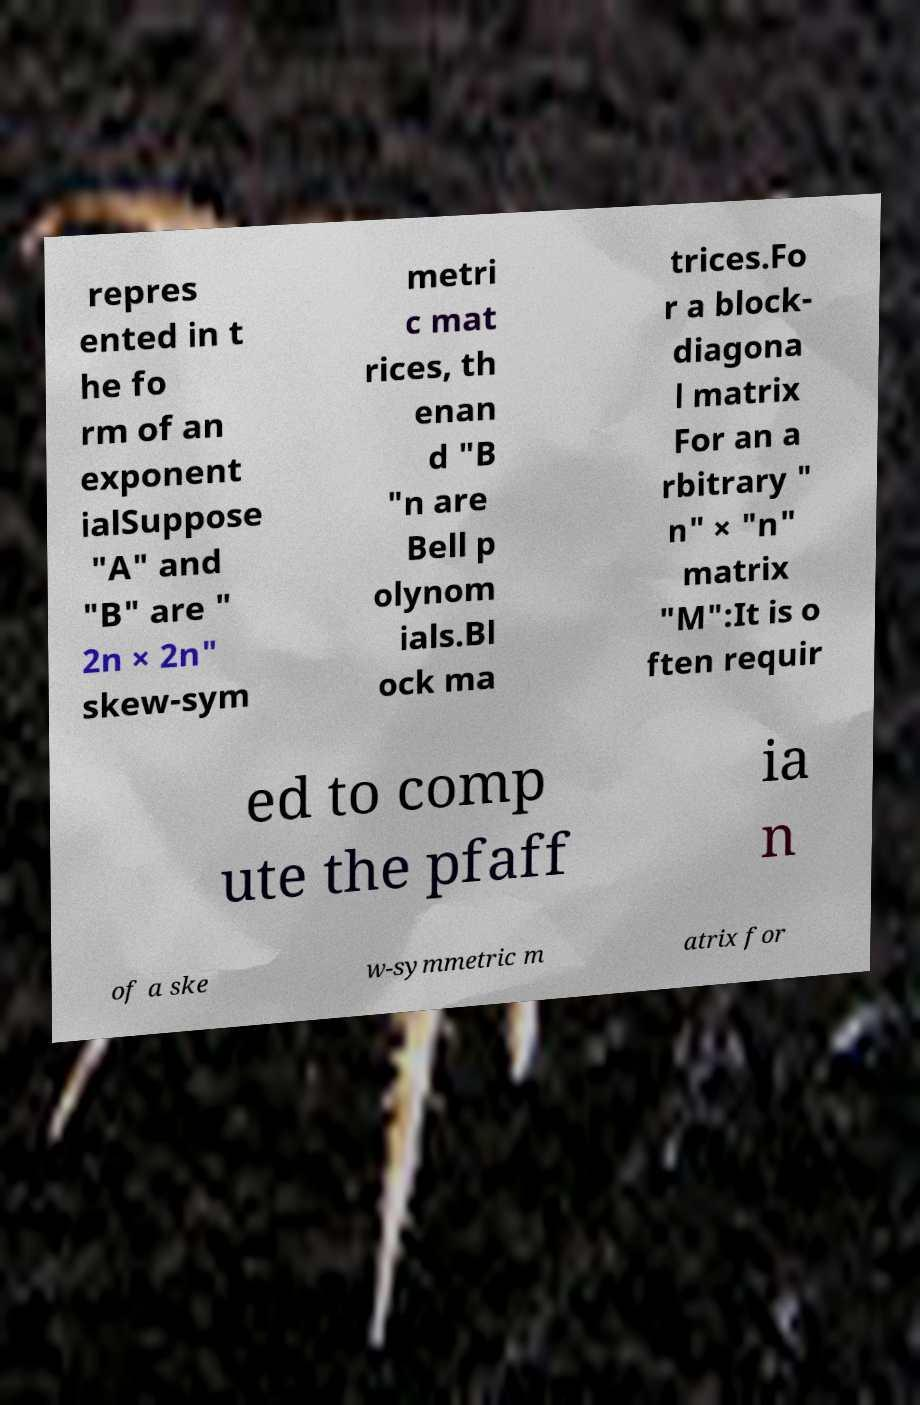Please read and relay the text visible in this image. What does it say? repres ented in t he fo rm of an exponent ialSuppose "A" and "B" are " 2n × 2n" skew-sym metri c mat rices, th enan d "B "n are Bell p olynom ials.Bl ock ma trices.Fo r a block- diagona l matrix For an a rbitrary " n" × "n" matrix "M":It is o ften requir ed to comp ute the pfaff ia n of a ske w-symmetric m atrix for 